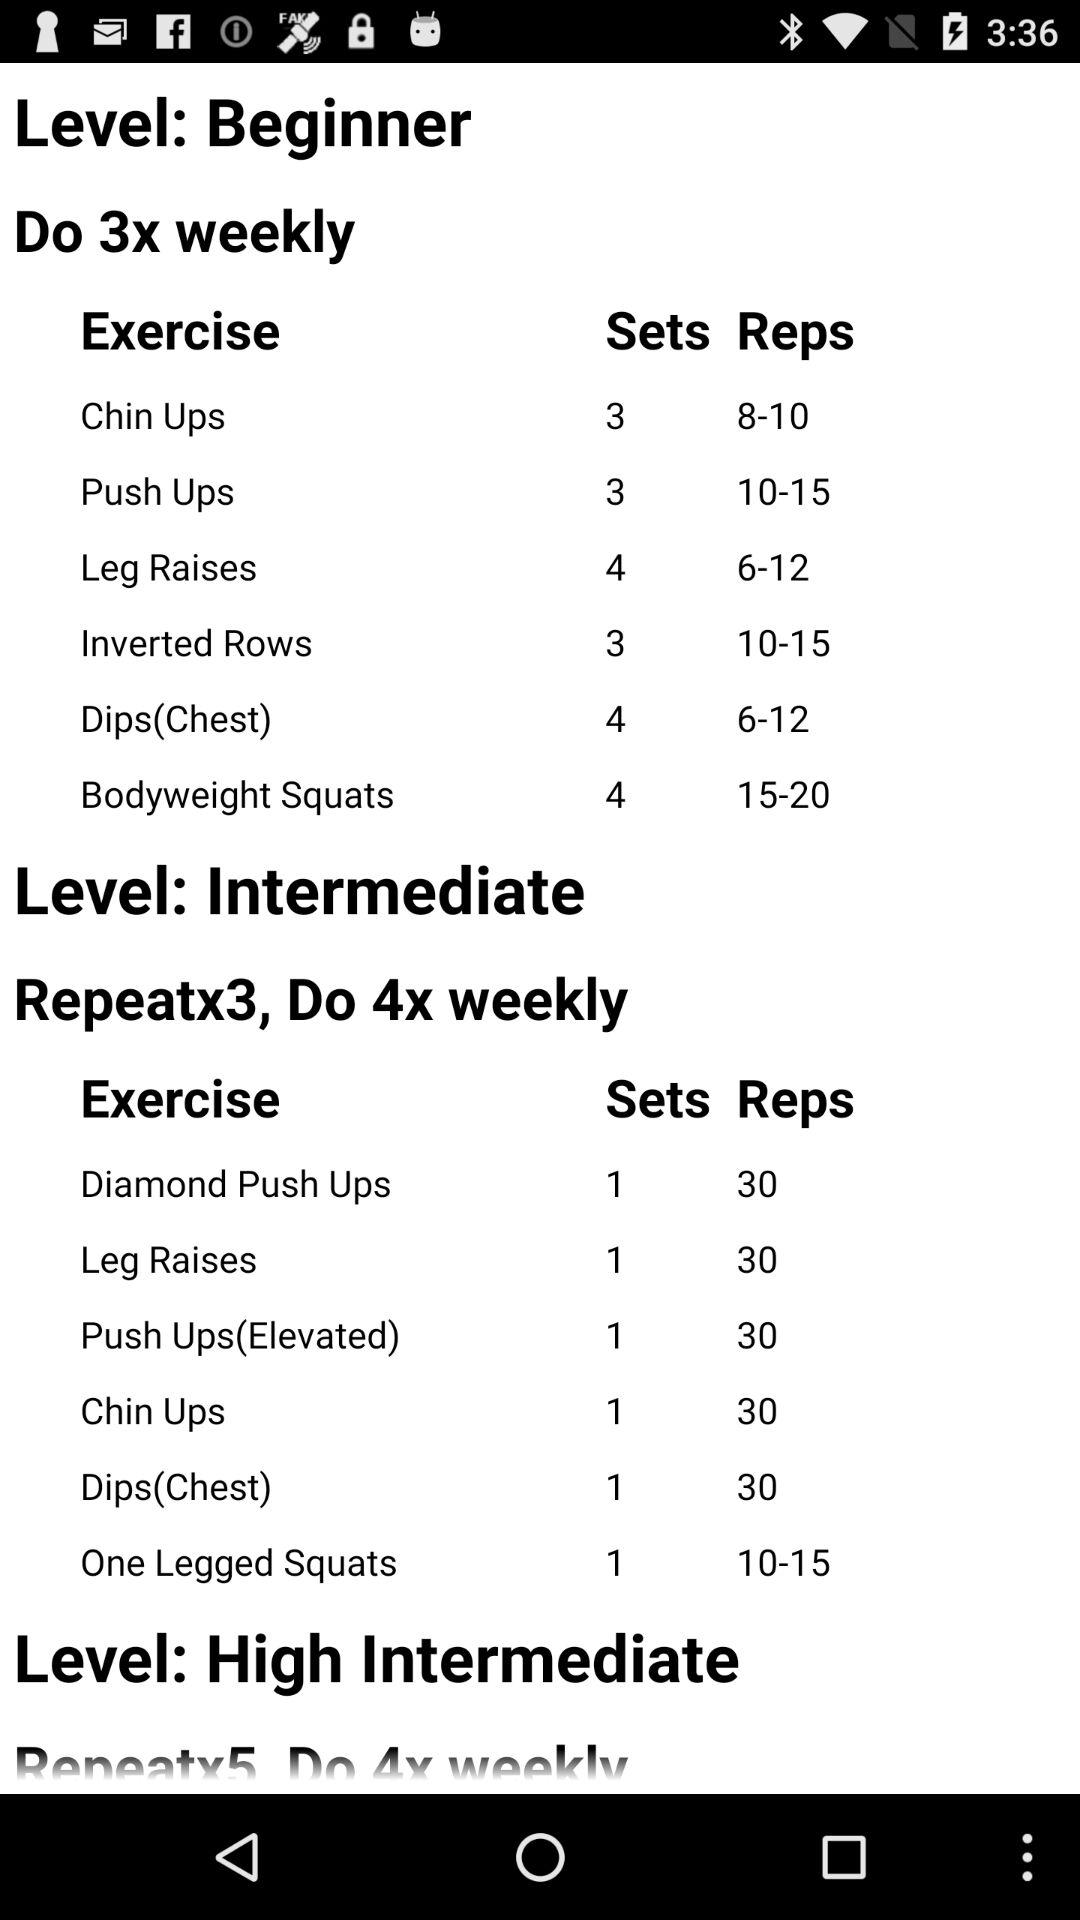How many times per week should we exercise at the intermediate level? At the intermediate level, you should exercise 4x per week. 